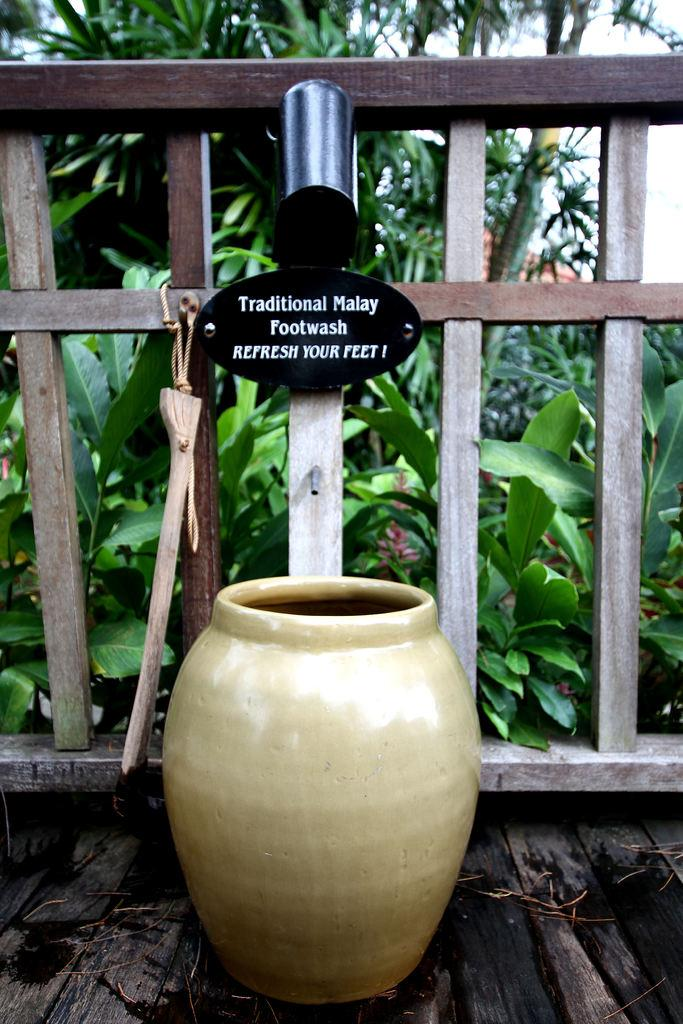What is placed on the wooden surface in the image? There is a container on a wooden surface. What can be seen in the image besides the container? There are many plants in the image. Is there any text visible in the image? Yes, there is a board with text written on it. What type of celery is being used as a decoration in the image? There is no celery present in the image; it features a container, plants, and a board with text. 